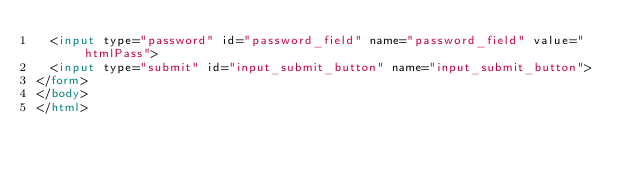Convert code to text. <code><loc_0><loc_0><loc_500><loc_500><_HTML_>  <input type="password" id="password_field" name="password_field" value="htmlPass">
  <input type="submit" id="input_submit_button" name="input_submit_button">
</form>
</body>
</html>
</code> 